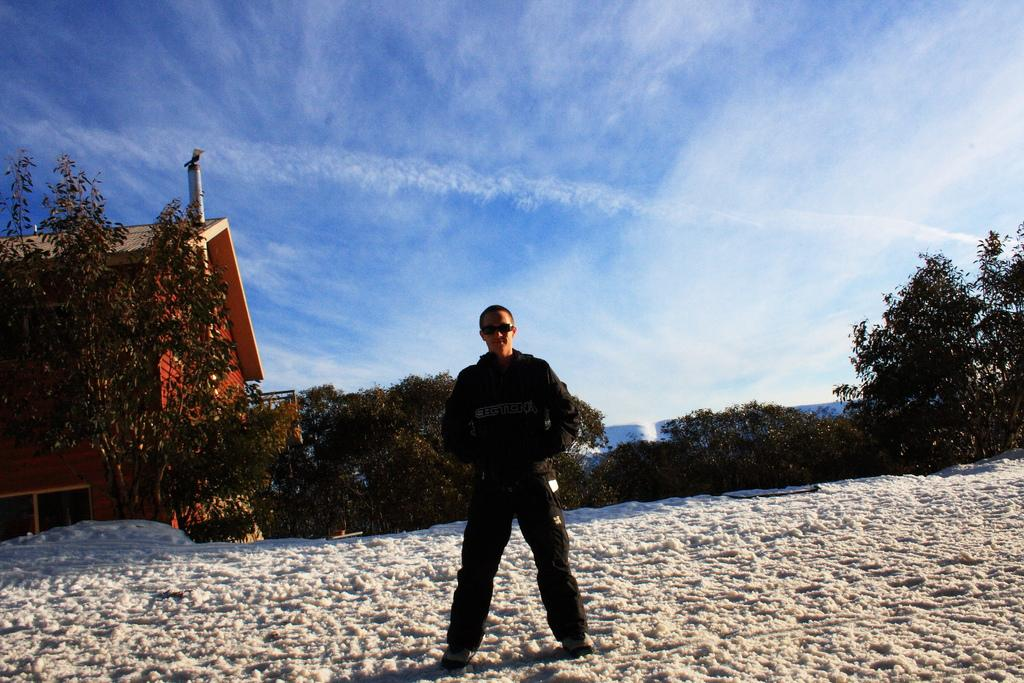What is the man in the image standing on? The man is standing on the snow in the image. What can be seen in the background of the image? There are trees and buildings in the backdrop of the image. How would you describe the sky in the image? The sky is clear in the image. What type of adjustment does the creator of the image make to the trees in the backdrop? There is no indication that the image has a creator, and the trees in the backdrop are not being adjusted in any way. 